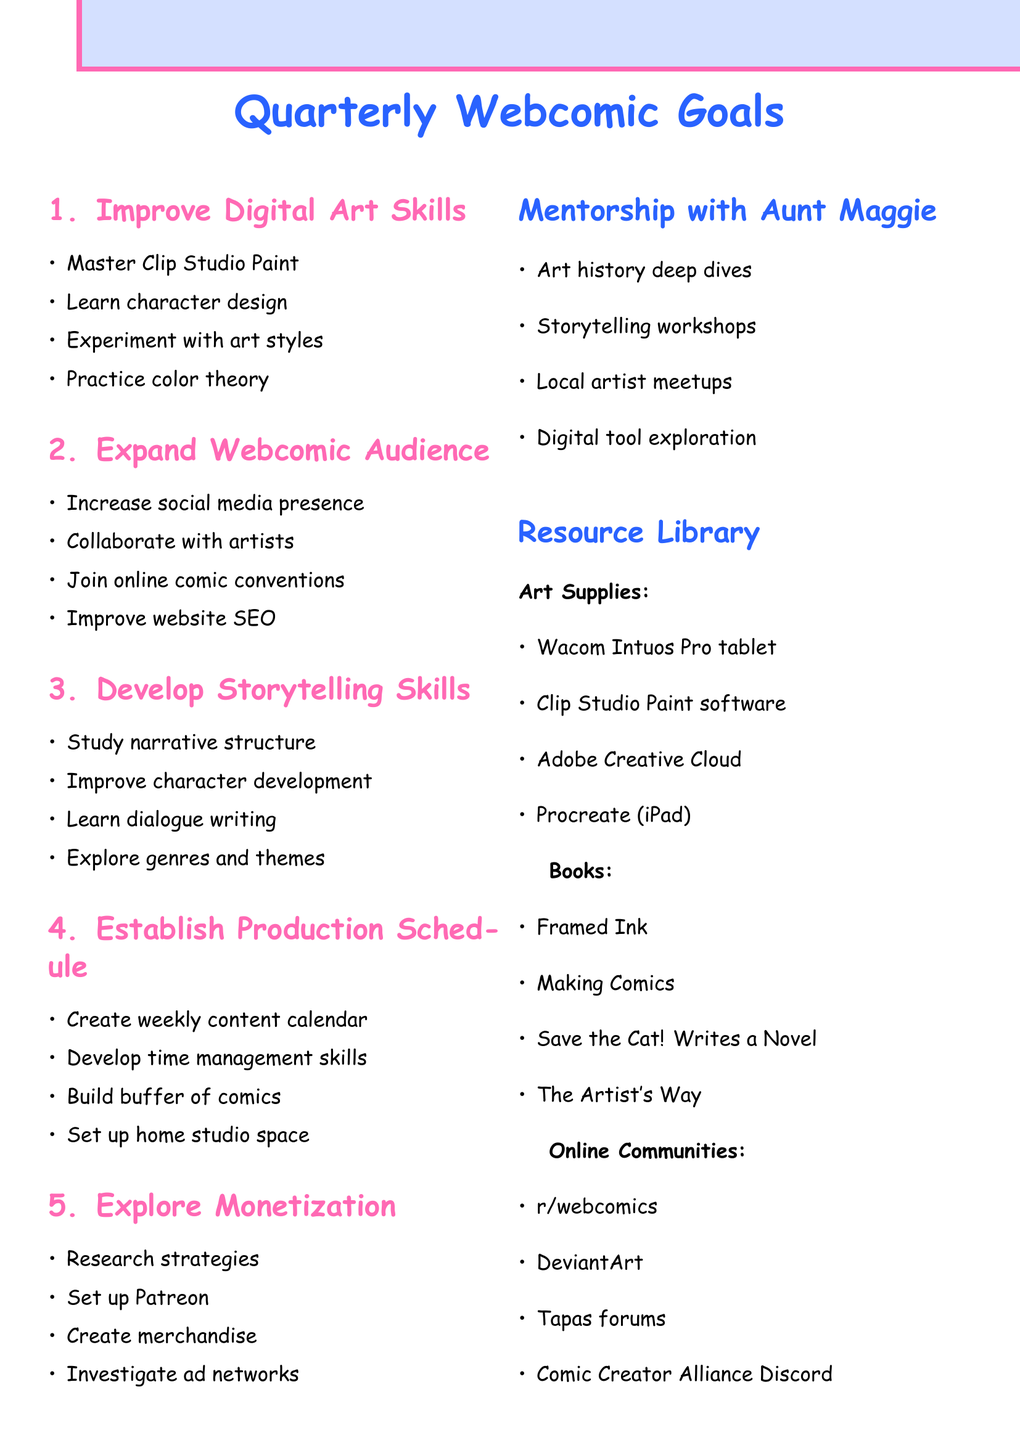what are the objectives for improving digital art skills? The document lists the goals: Master Clip Studio Paint's advanced features, Learn character design fundamentals, Experiment with different art styles, and Practice color theory and composition.
Answer: Master Clip Studio Paint's advanced features, Learn character design fundamentals, Experiment with different art styles, Practice color theory and composition who is the mentor mentioned in the plan? The document specifies the mentor as Aunt Maggie.
Answer: Aunt Maggie how many monthly sessions are planned with the mentor? The document details four monthly sessions to be held.
Answer: four what is one platform mentioned for creating merchandise? The document lists Redbubble as one of the platforms.
Answer: Redbubble which book is recommended for storytelling skills? The document mentions "Understanding Comics" by Scott McCloud as a resource.
Answer: "Understanding Comics" by Scott McCloud what is the primary software listed for digital art? The document specifies Clip Studio Paint software as the main software resource.
Answer: Clip Studio Paint software what is the aim for website improvement in expanding the webcomic audience? The document states the aim is to Improve website SEO and user experience.
Answer: Improve website SEO and user experience what technique is suggested for focused work sessions? The document recommends implementing the Pomodoro Technique.
Answer: Pomodoro Technique 